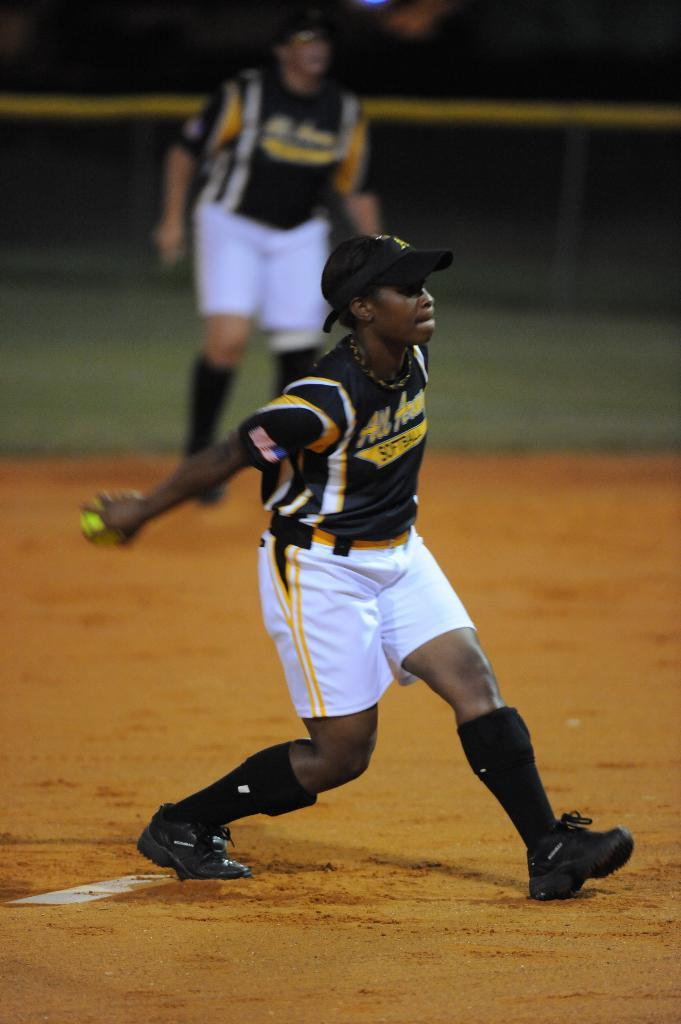<image>
Write a terse but informative summary of the picture. A woman with the word softball on her shirt is about to pitch the ball 